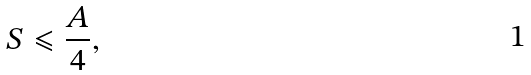Convert formula to latex. <formula><loc_0><loc_0><loc_500><loc_500>S \leqslant \frac { A } { 4 } ,</formula> 